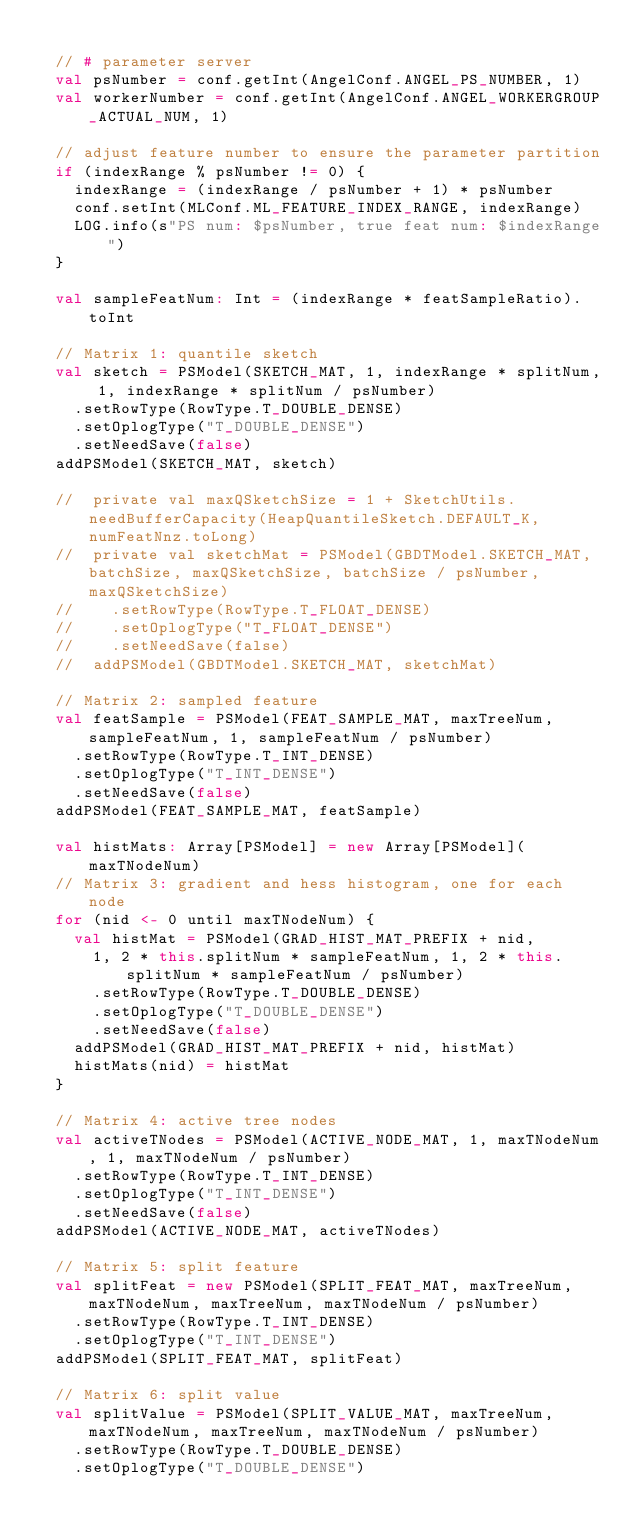Convert code to text. <code><loc_0><loc_0><loc_500><loc_500><_Scala_>
  // # parameter server
  val psNumber = conf.getInt(AngelConf.ANGEL_PS_NUMBER, 1)
  val workerNumber = conf.getInt(AngelConf.ANGEL_WORKERGROUP_ACTUAL_NUM, 1)

  // adjust feature number to ensure the parameter partition
  if (indexRange % psNumber != 0) {
    indexRange = (indexRange / psNumber + 1) * psNumber
    conf.setInt(MLConf.ML_FEATURE_INDEX_RANGE, indexRange)
    LOG.info(s"PS num: $psNumber, true feat num: $indexRange")
  }

  val sampleFeatNum: Int = (indexRange * featSampleRatio).toInt

  // Matrix 1: quantile sketch
  val sketch = PSModel(SKETCH_MAT, 1, indexRange * splitNum, 1, indexRange * splitNum / psNumber)
    .setRowType(RowType.T_DOUBLE_DENSE)
    .setOplogType("T_DOUBLE_DENSE")
    .setNeedSave(false)
  addPSModel(SKETCH_MAT, sketch)

  //  private val maxQSketchSize = 1 + SketchUtils.needBufferCapacity(HeapQuantileSketch.DEFAULT_K, numFeatNnz.toLong)
  //  private val sketchMat = PSModel(GBDTModel.SKETCH_MAT, batchSize, maxQSketchSize, batchSize / psNumber, maxQSketchSize)
  //    .setRowType(RowType.T_FLOAT_DENSE)
  //    .setOplogType("T_FLOAT_DENSE")
  //    .setNeedSave(false)
  //  addPSModel(GBDTModel.SKETCH_MAT, sketchMat)

  // Matrix 2: sampled feature
  val featSample = PSModel(FEAT_SAMPLE_MAT, maxTreeNum, sampleFeatNum, 1, sampleFeatNum / psNumber)
    .setRowType(RowType.T_INT_DENSE)
    .setOplogType("T_INT_DENSE")
    .setNeedSave(false)
  addPSModel(FEAT_SAMPLE_MAT, featSample)

  val histMats: Array[PSModel] = new Array[PSModel](maxTNodeNum)
  // Matrix 3: gradient and hess histogram, one for each node
  for (nid <- 0 until maxTNodeNum) {
    val histMat = PSModel(GRAD_HIST_MAT_PREFIX + nid,
      1, 2 * this.splitNum * sampleFeatNum, 1, 2 * this.splitNum * sampleFeatNum / psNumber)
      .setRowType(RowType.T_DOUBLE_DENSE)
      .setOplogType("T_DOUBLE_DENSE")
      .setNeedSave(false)
    addPSModel(GRAD_HIST_MAT_PREFIX + nid, histMat)
    histMats(nid) = histMat
  }

  // Matrix 4: active tree nodes
  val activeTNodes = PSModel(ACTIVE_NODE_MAT, 1, maxTNodeNum, 1, maxTNodeNum / psNumber)
    .setRowType(RowType.T_INT_DENSE)
    .setOplogType("T_INT_DENSE")
    .setNeedSave(false)
  addPSModel(ACTIVE_NODE_MAT, activeTNodes)

  // Matrix 5: split feature
  val splitFeat = new PSModel(SPLIT_FEAT_MAT, maxTreeNum, maxTNodeNum, maxTreeNum, maxTNodeNum / psNumber)
    .setRowType(RowType.T_INT_DENSE)
    .setOplogType("T_INT_DENSE")
  addPSModel(SPLIT_FEAT_MAT, splitFeat)

  // Matrix 6: split value
  val splitValue = PSModel(SPLIT_VALUE_MAT, maxTreeNum, maxTNodeNum, maxTreeNum, maxTNodeNum / psNumber)
    .setRowType(RowType.T_DOUBLE_DENSE)
    .setOplogType("T_DOUBLE_DENSE")</code> 